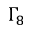Convert formula to latex. <formula><loc_0><loc_0><loc_500><loc_500>\Gamma _ { 8 }</formula> 